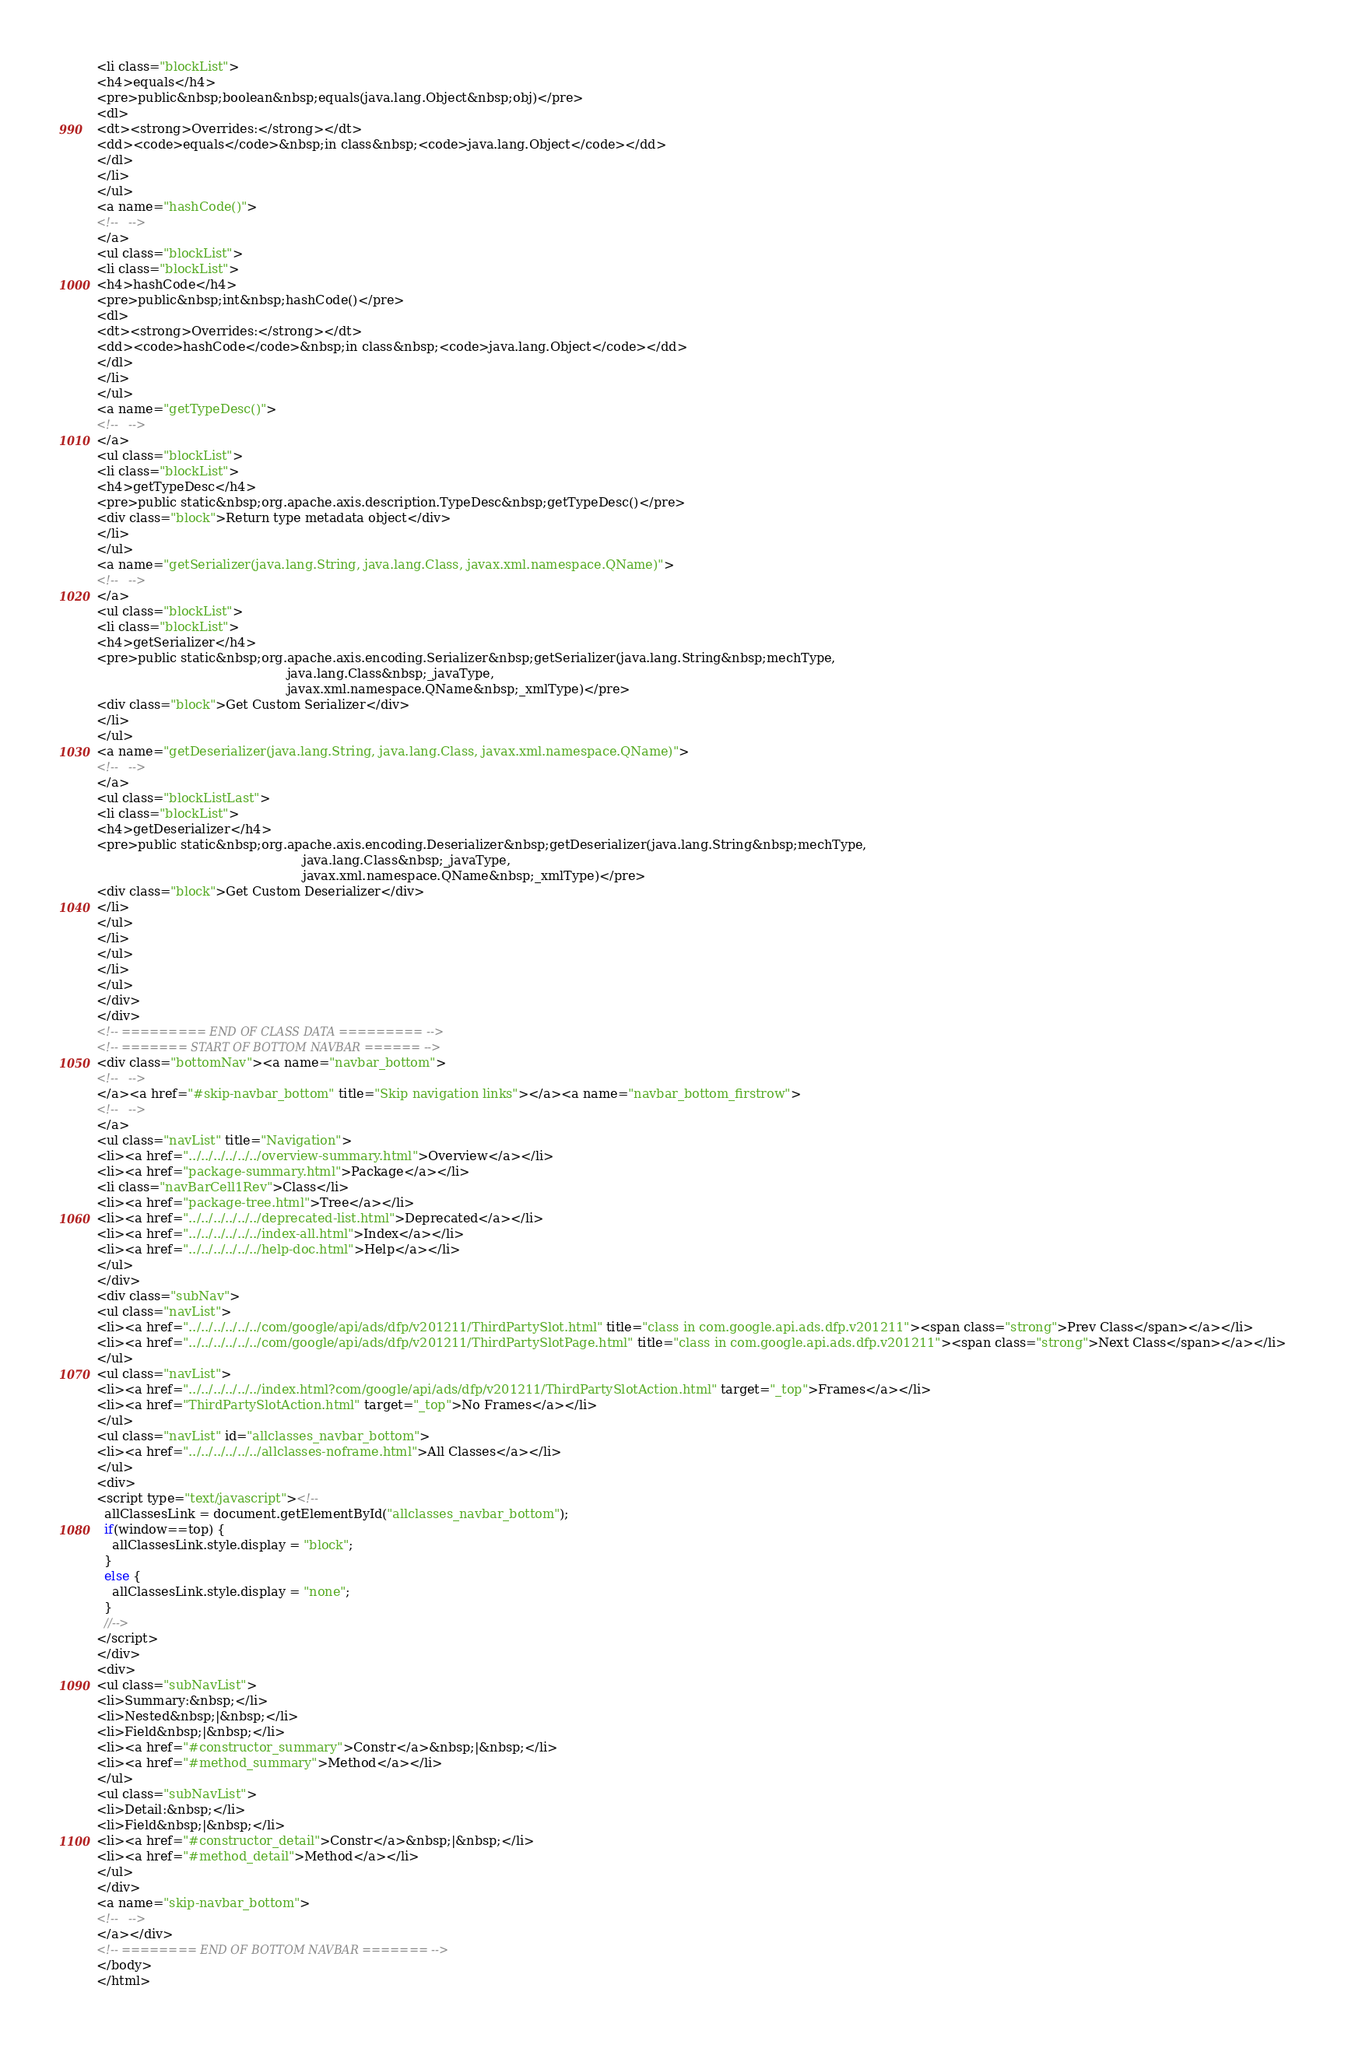Convert code to text. <code><loc_0><loc_0><loc_500><loc_500><_HTML_><li class="blockList">
<h4>equals</h4>
<pre>public&nbsp;boolean&nbsp;equals(java.lang.Object&nbsp;obj)</pre>
<dl>
<dt><strong>Overrides:</strong></dt>
<dd><code>equals</code>&nbsp;in class&nbsp;<code>java.lang.Object</code></dd>
</dl>
</li>
</ul>
<a name="hashCode()">
<!--   -->
</a>
<ul class="blockList">
<li class="blockList">
<h4>hashCode</h4>
<pre>public&nbsp;int&nbsp;hashCode()</pre>
<dl>
<dt><strong>Overrides:</strong></dt>
<dd><code>hashCode</code>&nbsp;in class&nbsp;<code>java.lang.Object</code></dd>
</dl>
</li>
</ul>
<a name="getTypeDesc()">
<!--   -->
</a>
<ul class="blockList">
<li class="blockList">
<h4>getTypeDesc</h4>
<pre>public static&nbsp;org.apache.axis.description.TypeDesc&nbsp;getTypeDesc()</pre>
<div class="block">Return type metadata object</div>
</li>
</ul>
<a name="getSerializer(java.lang.String, java.lang.Class, javax.xml.namespace.QName)">
<!--   -->
</a>
<ul class="blockList">
<li class="blockList">
<h4>getSerializer</h4>
<pre>public static&nbsp;org.apache.axis.encoding.Serializer&nbsp;getSerializer(java.lang.String&nbsp;mechType,
                                                java.lang.Class&nbsp;_javaType,
                                                javax.xml.namespace.QName&nbsp;_xmlType)</pre>
<div class="block">Get Custom Serializer</div>
</li>
</ul>
<a name="getDeserializer(java.lang.String, java.lang.Class, javax.xml.namespace.QName)">
<!--   -->
</a>
<ul class="blockListLast">
<li class="blockList">
<h4>getDeserializer</h4>
<pre>public static&nbsp;org.apache.axis.encoding.Deserializer&nbsp;getDeserializer(java.lang.String&nbsp;mechType,
                                                    java.lang.Class&nbsp;_javaType,
                                                    javax.xml.namespace.QName&nbsp;_xmlType)</pre>
<div class="block">Get Custom Deserializer</div>
</li>
</ul>
</li>
</ul>
</li>
</ul>
</div>
</div>
<!-- ========= END OF CLASS DATA ========= -->
<!-- ======= START OF BOTTOM NAVBAR ====== -->
<div class="bottomNav"><a name="navbar_bottom">
<!--   -->
</a><a href="#skip-navbar_bottom" title="Skip navigation links"></a><a name="navbar_bottom_firstrow">
<!--   -->
</a>
<ul class="navList" title="Navigation">
<li><a href="../../../../../../overview-summary.html">Overview</a></li>
<li><a href="package-summary.html">Package</a></li>
<li class="navBarCell1Rev">Class</li>
<li><a href="package-tree.html">Tree</a></li>
<li><a href="../../../../../../deprecated-list.html">Deprecated</a></li>
<li><a href="../../../../../../index-all.html">Index</a></li>
<li><a href="../../../../../../help-doc.html">Help</a></li>
</ul>
</div>
<div class="subNav">
<ul class="navList">
<li><a href="../../../../../../com/google/api/ads/dfp/v201211/ThirdPartySlot.html" title="class in com.google.api.ads.dfp.v201211"><span class="strong">Prev Class</span></a></li>
<li><a href="../../../../../../com/google/api/ads/dfp/v201211/ThirdPartySlotPage.html" title="class in com.google.api.ads.dfp.v201211"><span class="strong">Next Class</span></a></li>
</ul>
<ul class="navList">
<li><a href="../../../../../../index.html?com/google/api/ads/dfp/v201211/ThirdPartySlotAction.html" target="_top">Frames</a></li>
<li><a href="ThirdPartySlotAction.html" target="_top">No Frames</a></li>
</ul>
<ul class="navList" id="allclasses_navbar_bottom">
<li><a href="../../../../../../allclasses-noframe.html">All Classes</a></li>
</ul>
<div>
<script type="text/javascript"><!--
  allClassesLink = document.getElementById("allclasses_navbar_bottom");
  if(window==top) {
    allClassesLink.style.display = "block";
  }
  else {
    allClassesLink.style.display = "none";
  }
  //-->
</script>
</div>
<div>
<ul class="subNavList">
<li>Summary:&nbsp;</li>
<li>Nested&nbsp;|&nbsp;</li>
<li>Field&nbsp;|&nbsp;</li>
<li><a href="#constructor_summary">Constr</a>&nbsp;|&nbsp;</li>
<li><a href="#method_summary">Method</a></li>
</ul>
<ul class="subNavList">
<li>Detail:&nbsp;</li>
<li>Field&nbsp;|&nbsp;</li>
<li><a href="#constructor_detail">Constr</a>&nbsp;|&nbsp;</li>
<li><a href="#method_detail">Method</a></li>
</ul>
</div>
<a name="skip-navbar_bottom">
<!--   -->
</a></div>
<!-- ======== END OF BOTTOM NAVBAR ======= -->
</body>
</html>
</code> 